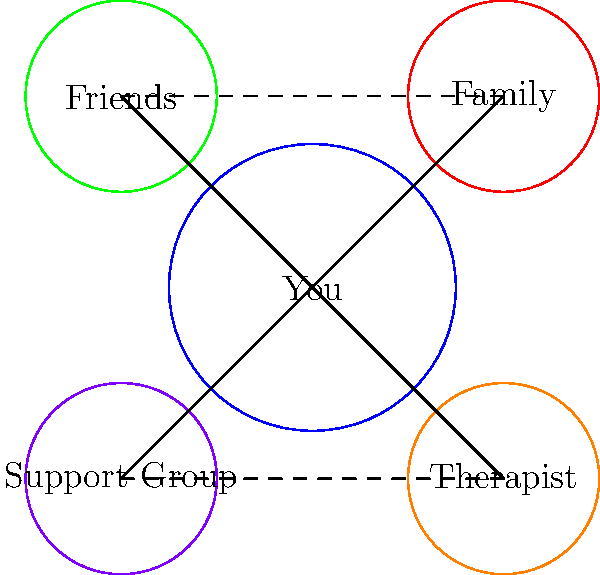In the context of healing from police brutality, which support network component is represented by the largest circle in the diagram, and how many direct connections does it have to other components? To answer this question, we need to analyze the network diagram step by step:

1. Identify the circles:
   - Blue circle (center): "You"
   - Red circle (top right): "Family"
   - Green circle (top left): "Friends"
   - Orange circle (bottom right): "Therapist"
   - Purple circle (bottom left): "Support Group"

2. Determine the largest circle:
   The blue circle in the center, labeled "You," is visibly larger than the other circles.

3. Count the direct connections from the largest circle:
   - There is a solid line connecting "You" to "Family"
   - There is a solid line connecting "You" to "Friends"
   - There is a solid line connecting "You" to "Therapist"
   - There is a solid line connecting "You" to "Support Group"

4. Sum up the total number of direct connections:
   The "You" circle has 4 direct connections to other components of the support network.

Therefore, the largest circle represents "You" in the healing journey, and it has 4 direct connections to other support network components.
Answer: "You"; 4 connections 